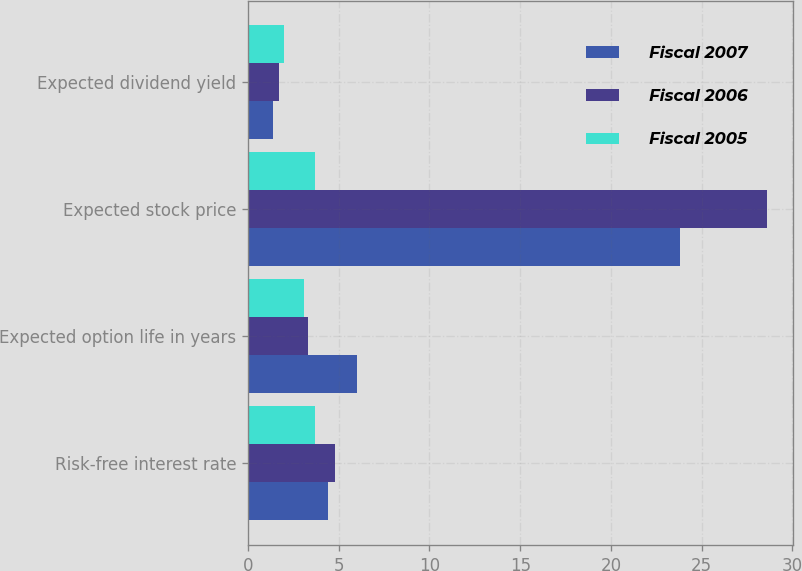Convert chart to OTSL. <chart><loc_0><loc_0><loc_500><loc_500><stacked_bar_chart><ecel><fcel>Risk-free interest rate<fcel>Expected option life in years<fcel>Expected stock price<fcel>Expected dividend yield<nl><fcel>Fiscal 2007<fcel>4.4<fcel>6<fcel>23.8<fcel>1.4<nl><fcel>Fiscal 2006<fcel>4.8<fcel>3.3<fcel>28.6<fcel>1.7<nl><fcel>Fiscal 2005<fcel>3.7<fcel>3.1<fcel>3.7<fcel>2<nl></chart> 